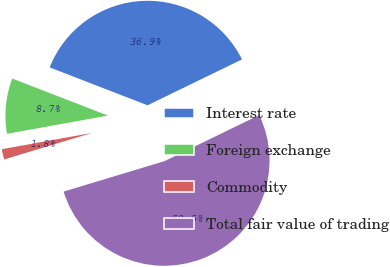Convert chart to OTSL. <chart><loc_0><loc_0><loc_500><loc_500><pie_chart><fcel>Interest rate<fcel>Foreign exchange<fcel>Commodity<fcel>Total fair value of trading<nl><fcel>36.92%<fcel>8.72%<fcel>1.82%<fcel>52.53%<nl></chart> 